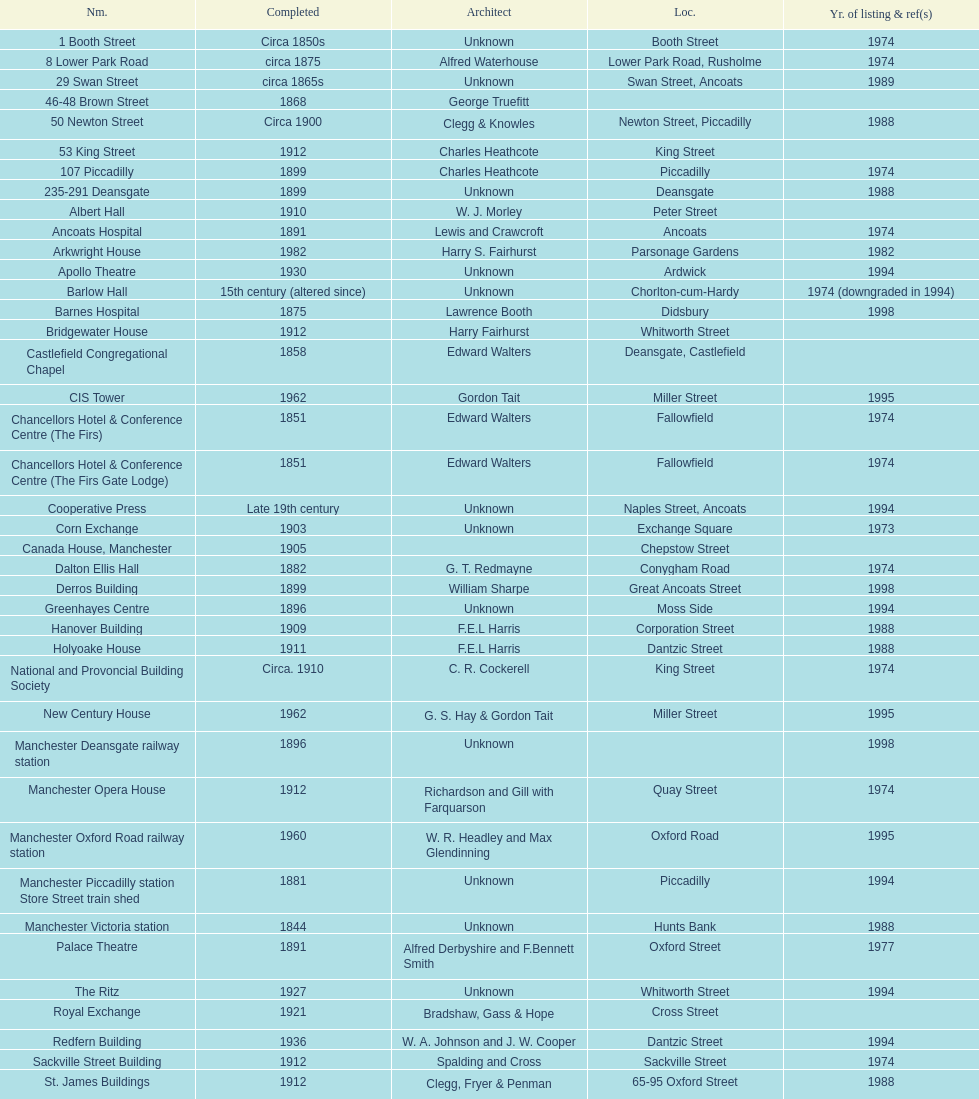How many buildings do not have an image listed? 11. 